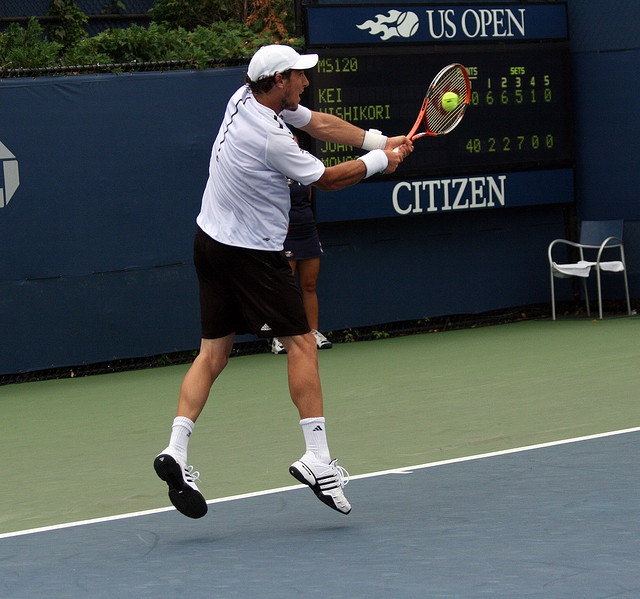Describe the objects in this image and their specific colors. I can see people in black, lavender, darkgray, and brown tones, chair in black, navy, gray, and darkgray tones, people in black, maroon, darkgray, and gray tones, tennis racket in black, maroon, tan, and olive tones, and sports ball in black, khaki, olive, and lightgreen tones in this image. 